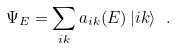<formula> <loc_0><loc_0><loc_500><loc_500>\Psi _ { E } = \sum _ { i k } a _ { i k } ( E ) \, | i k \rangle \ .</formula> 